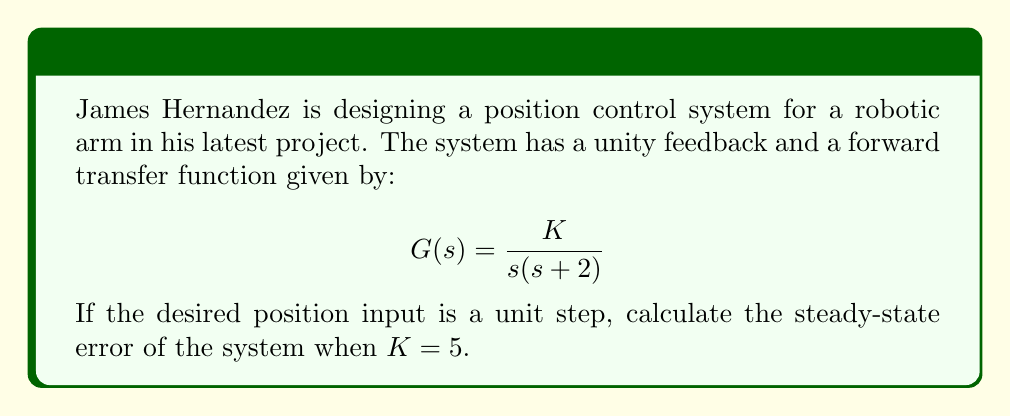Show me your answer to this math problem. To solve this problem, we'll follow these steps:

1) First, recall that for a unity feedback system, the steady-state error for a step input is given by:

   $$e_{ss} = \lim_{s \to 0} \frac{s}{1 + G(s)}$$

2) We're given that $G(s) = \frac{K}{s(s+2)}$ and $K = 5$. Let's substitute these into our equation:

   $$e_{s} = \lim_{s \to 0} \frac{s}{1 + \frac{5}{s(s+2)}}$$

3) To evaluate this limit, let's multiply both numerator and denominator by $s(s+2)$:

   $$e_{s} = \lim_{s \to 0} \frac{s^2(s+2)}{s(s+2) + 5}$$

4) Now, as $s$ approaches 0, the higher order terms in $s$ will approach 0 faster. So we can simplify:

   $$e_{s} = \lim_{s \to 0} \frac{0 + 0 + 0}{0 + 0 + 5} = \frac{0}{5} = 0$$

5) Therefore, the steady-state error is 0.

This makes sense physically. The system is Type 1 (it has one free integrator in the forward path), which means it can track a step input with zero steady-state error.
Answer: The steady-state error of the position control system is 0. 